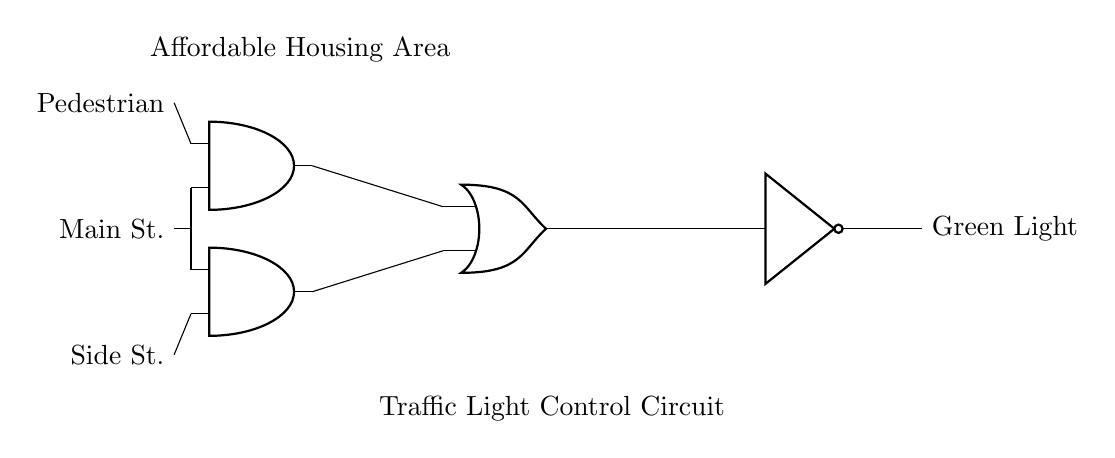What type of gate is used to control the traffic light? The circuit uses AND, OR, and NOT gates to control the traffic light based on pedestrian and vehicle inputs.
Answer: AND, OR, NOT How many inputs are connected to the AND gates? Each AND gate has two inputs connected; one is from the pedestrian signal and the other is from the street signal.
Answer: Two What is the purpose of the NOT gate in this circuit? The NOT gate inverts the output of the OR gate, which is necessary for changing the signal of the traffic light to green when conditions are met.
Answer: Inversion What signals cause the green light to activate? The green light activates when both the pedestrian input and either the main street input or side street input cause the AND gates to output a signal to the OR gate.
Answer: Pedestrian and street signals What does the output of the OR gate indicate? The output of the OR gate indicates readiness for the traffic light to change to green based on inputs from the AND gates, meaning either street or pedestrian activation is sufficient.
Answer: Traffic light readiness If neither street is active, what happens to the traffic light? If neither the main street nor the side street inputs are active while the pedestrian input is active, it provides no signal to the AND gates, thus the green light stays off.
Answer: Light stays off 